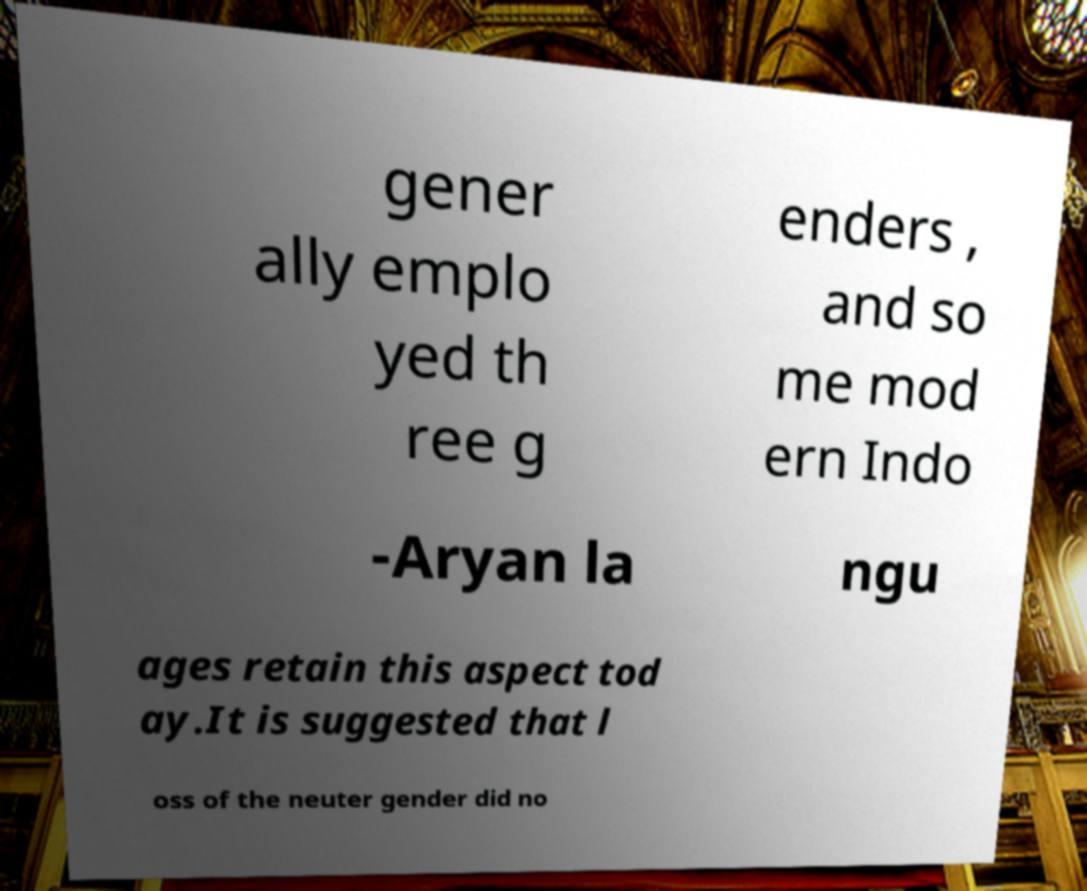For documentation purposes, I need the text within this image transcribed. Could you provide that? gener ally emplo yed th ree g enders , and so me mod ern Indo -Aryan la ngu ages retain this aspect tod ay.It is suggested that l oss of the neuter gender did no 